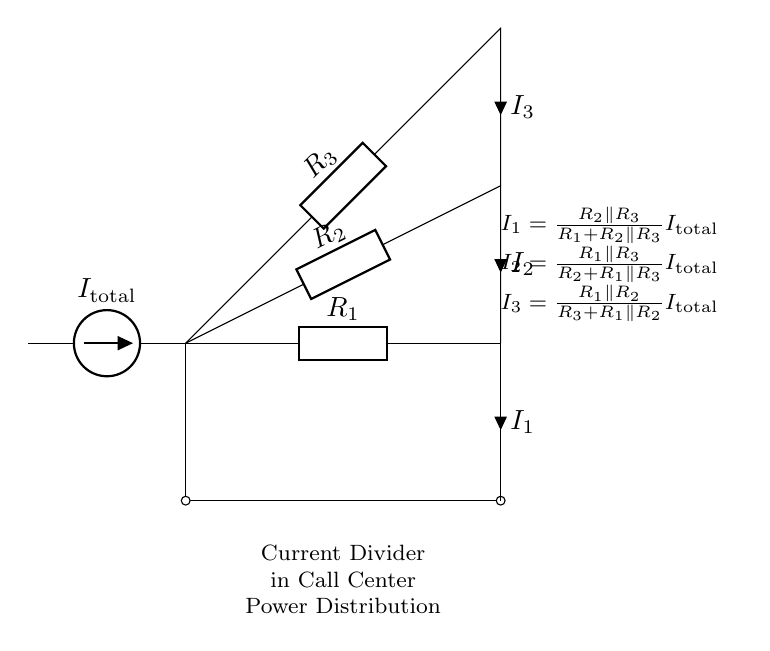What is the value of I total? I total is the current supplied by the current source. In this circuit, it is represented as I total in the schematic.
Answer: I total What are the components connected in parallel? The components connected in parallel in this current divider circuit are R 2 and R 3. They share the same voltage across their terminals and will divide the total current based on their resistance values.
Answer: R 2 and R 3 What current flows through R 1? The current flowing through R 1 is I 1, as it is the part of the circuit where the total current splits to flow through the resistors, and the direction of I 1 indicates flow through R 1.
Answer: I 1 What is the relationship between I 1, I 2, and I 3? The currents I 1, I 2, and I 3 represent the divided currents in the circuit, where each is based on different resistance paths that modify how the total current I total is split among them. Each current’s value depends on the resistor values and the total current.
Answer: I total = I 1 + I 2 + I 3 Which component influences I 3 the most? The component that influences I 3 the most would be the resistor R 3, as its value directly affects the portion of current that flows through it, relative to the total current I total.
Answer: R 3 